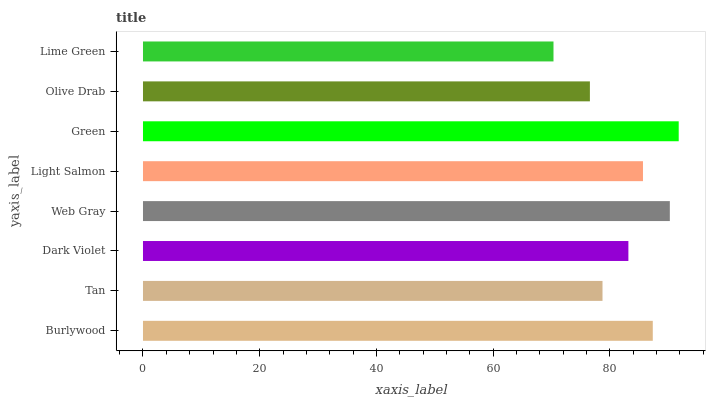Is Lime Green the minimum?
Answer yes or no. Yes. Is Green the maximum?
Answer yes or no. Yes. Is Tan the minimum?
Answer yes or no. No. Is Tan the maximum?
Answer yes or no. No. Is Burlywood greater than Tan?
Answer yes or no. Yes. Is Tan less than Burlywood?
Answer yes or no. Yes. Is Tan greater than Burlywood?
Answer yes or no. No. Is Burlywood less than Tan?
Answer yes or no. No. Is Light Salmon the high median?
Answer yes or no. Yes. Is Dark Violet the low median?
Answer yes or no. Yes. Is Olive Drab the high median?
Answer yes or no. No. Is Burlywood the low median?
Answer yes or no. No. 